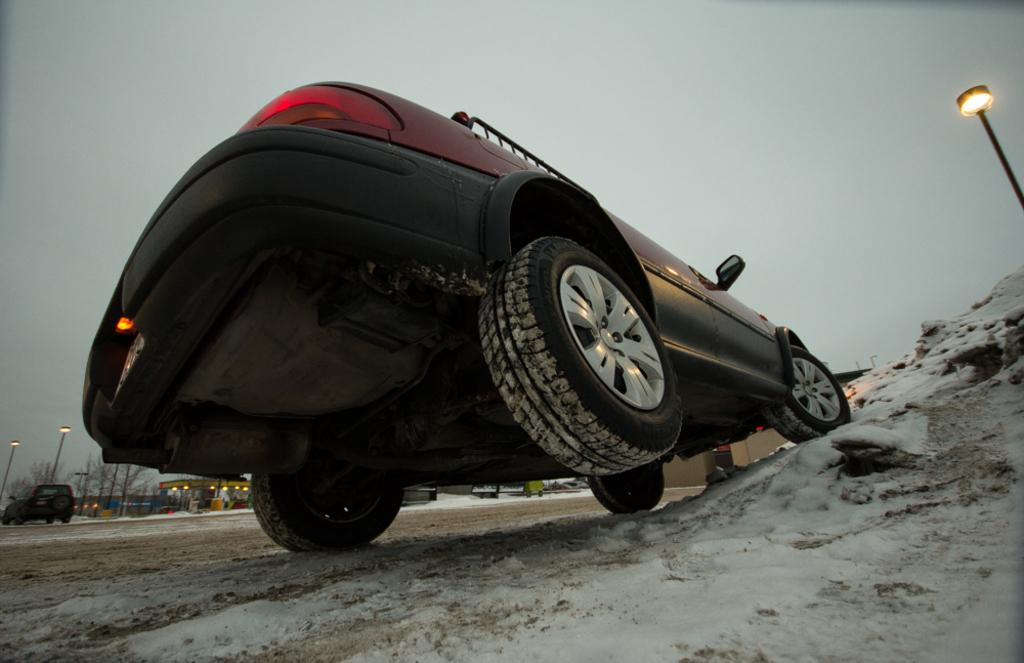What type of structures can be seen in the image? There are buildings in the image. What type of vehicles are present in the image? There are cars in the image. What type of vegetation is visible in the image? There are trees in the image. What type of lighting is present in the image? There are pole lights in the image. What is covering the ground in the image? There is snow on the ground in the image. What is the condition of the sky in the image? The sky is cloudy in the image. What is the rate of the song being played in the image? There is no song being played in the image, so there is no rate to determine. What fact can be learned about the trees in the image? The fact that there are trees in the image is already known, so there is no additional fact to learn about them in this context. 